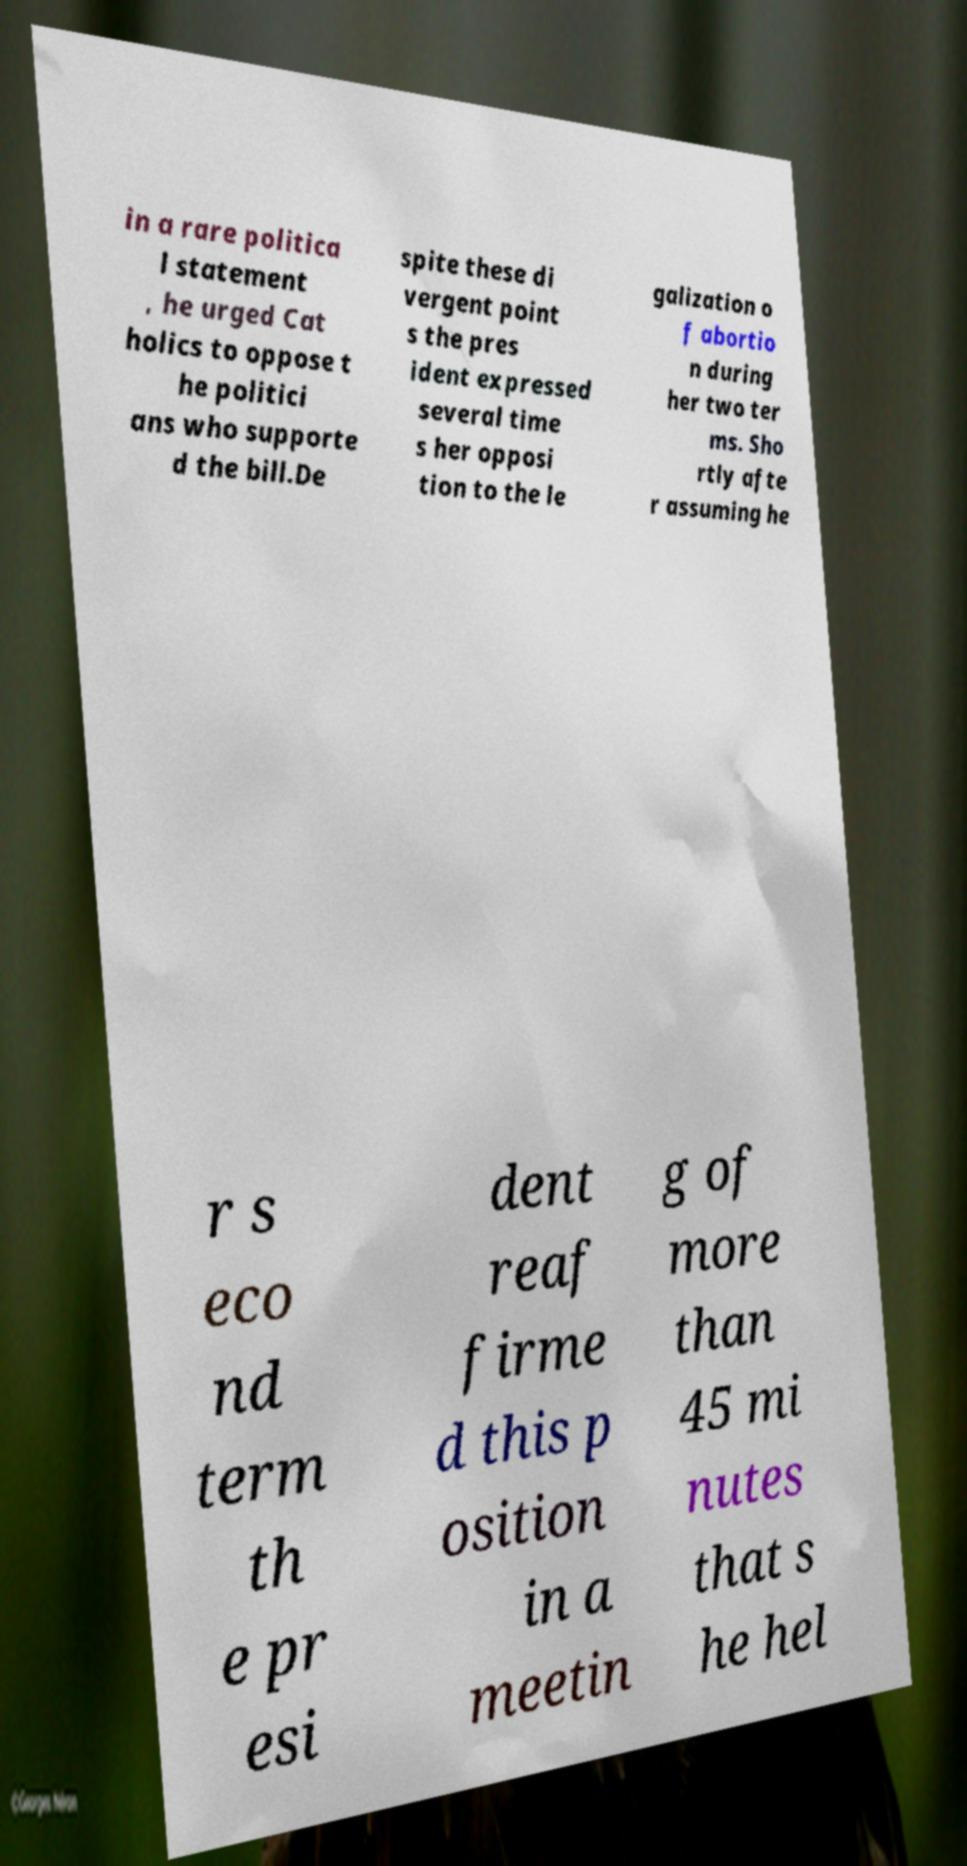Could you extract and type out the text from this image? in a rare politica l statement , he urged Cat holics to oppose t he politici ans who supporte d the bill.De spite these di vergent point s the pres ident expressed several time s her opposi tion to the le galization o f abortio n during her two ter ms. Sho rtly afte r assuming he r s eco nd term th e pr esi dent reaf firme d this p osition in a meetin g of more than 45 mi nutes that s he hel 